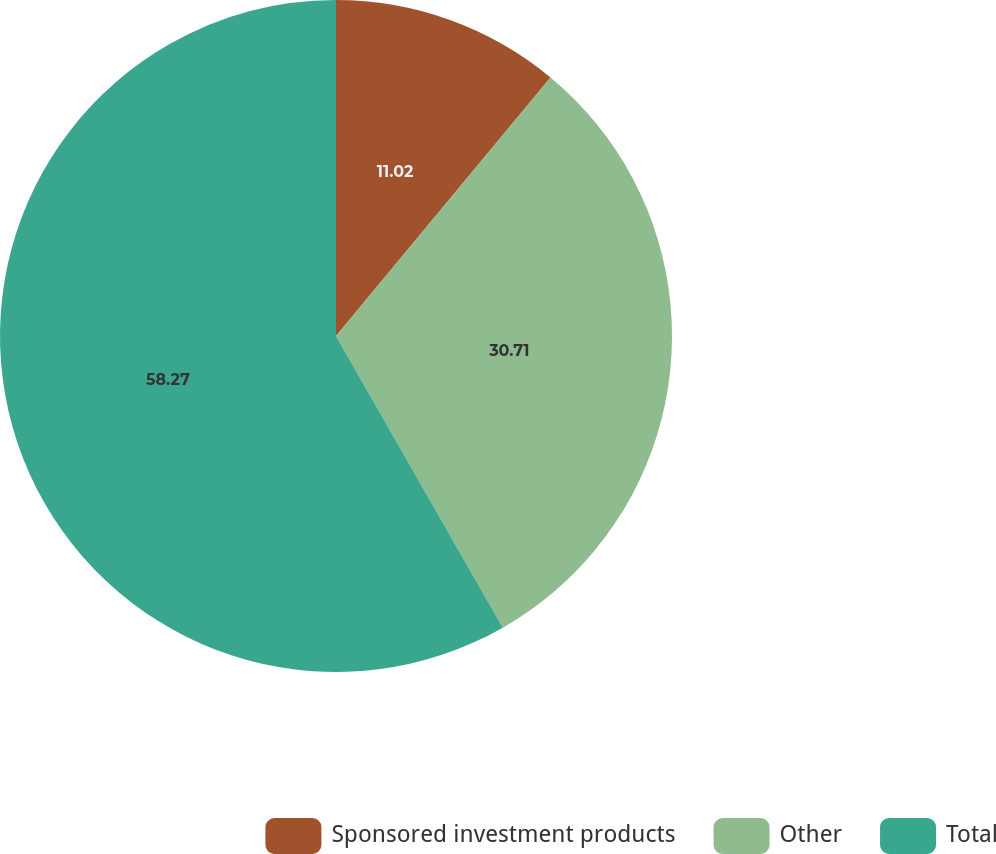Convert chart to OTSL. <chart><loc_0><loc_0><loc_500><loc_500><pie_chart><fcel>Sponsored investment products<fcel>Other<fcel>Total<nl><fcel>11.02%<fcel>30.71%<fcel>58.27%<nl></chart> 